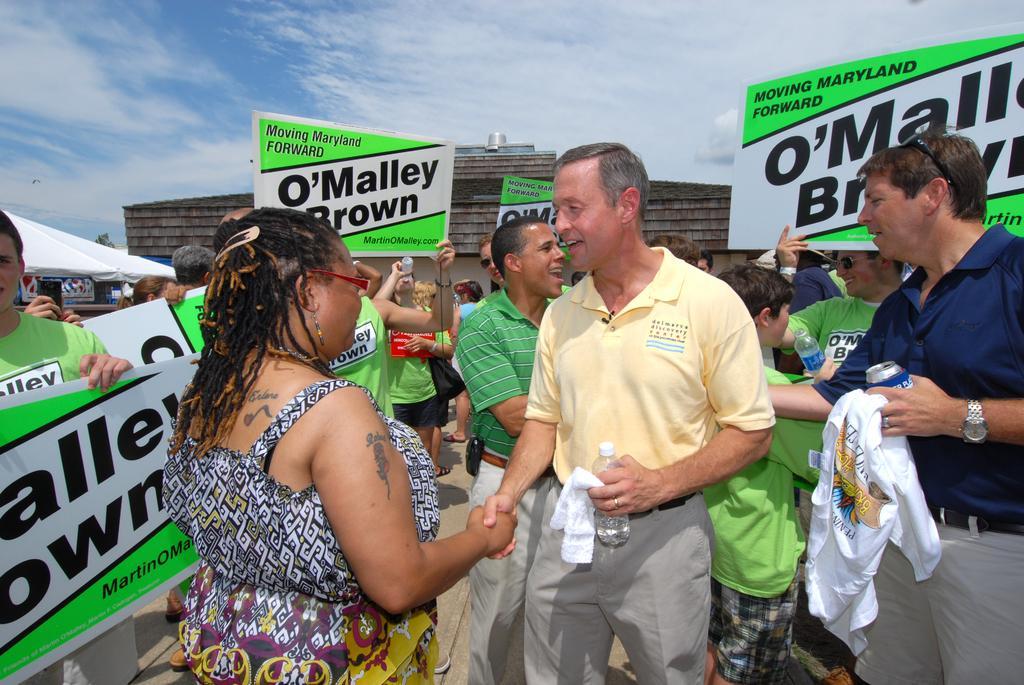Can you describe this image briefly? In this picture we can observe some people standing. Most of them are wearing green color t-shirt and holding white and green color boards in their hands. There are men and women in this picture. We can observe white color tint on the left side. In the background there is a brown color building and sky with some clouds. 